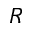<formula> <loc_0><loc_0><loc_500><loc_500>R</formula> 